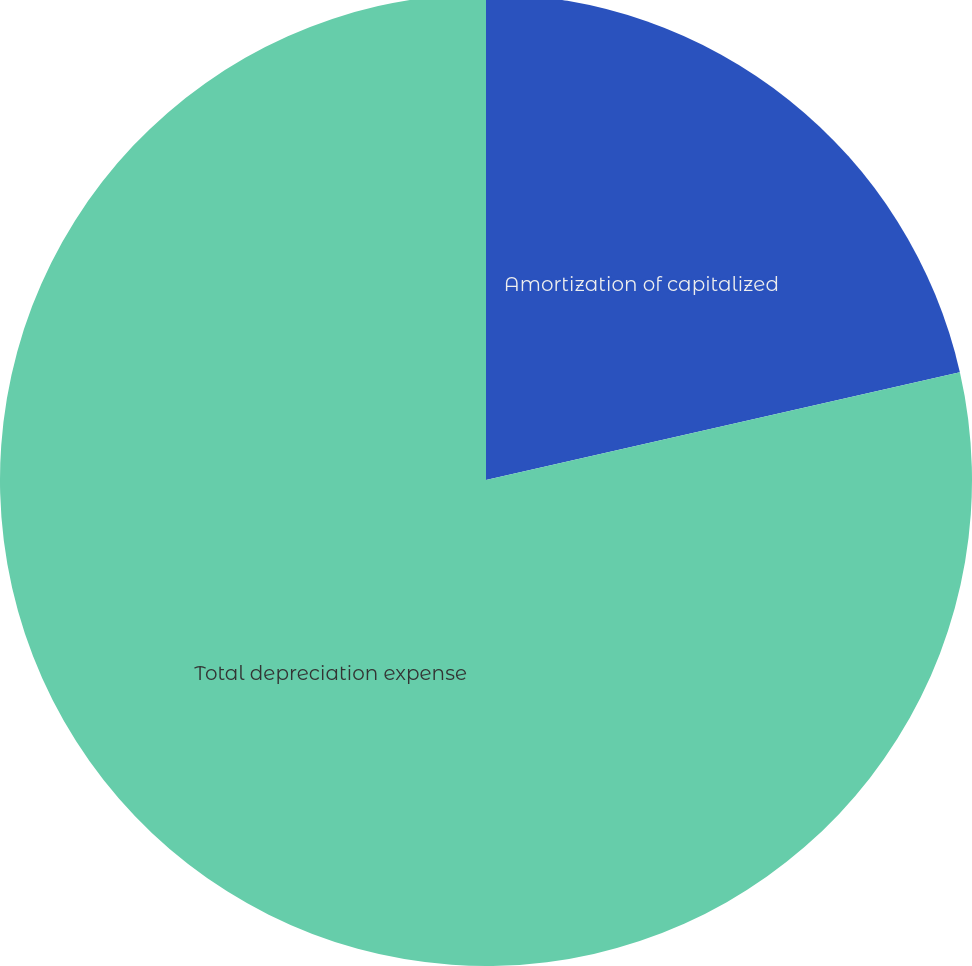<chart> <loc_0><loc_0><loc_500><loc_500><pie_chart><fcel>Amortization of capitalized<fcel>Total depreciation expense<nl><fcel>21.44%<fcel>78.56%<nl></chart> 